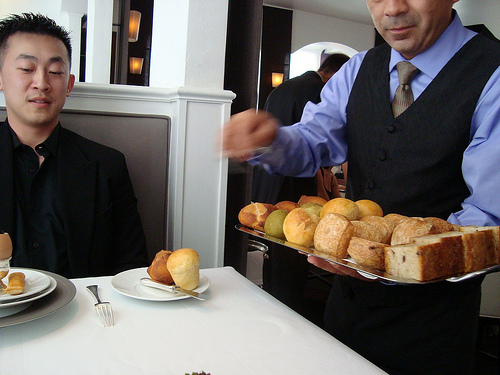<image>
Is the man to the right of the table? Yes. From this viewpoint, the man is positioned to the right side relative to the table. Is there a fork on the plate? No. The fork is not positioned on the plate. They may be near each other, but the fork is not supported by or resting on top of the plate. 